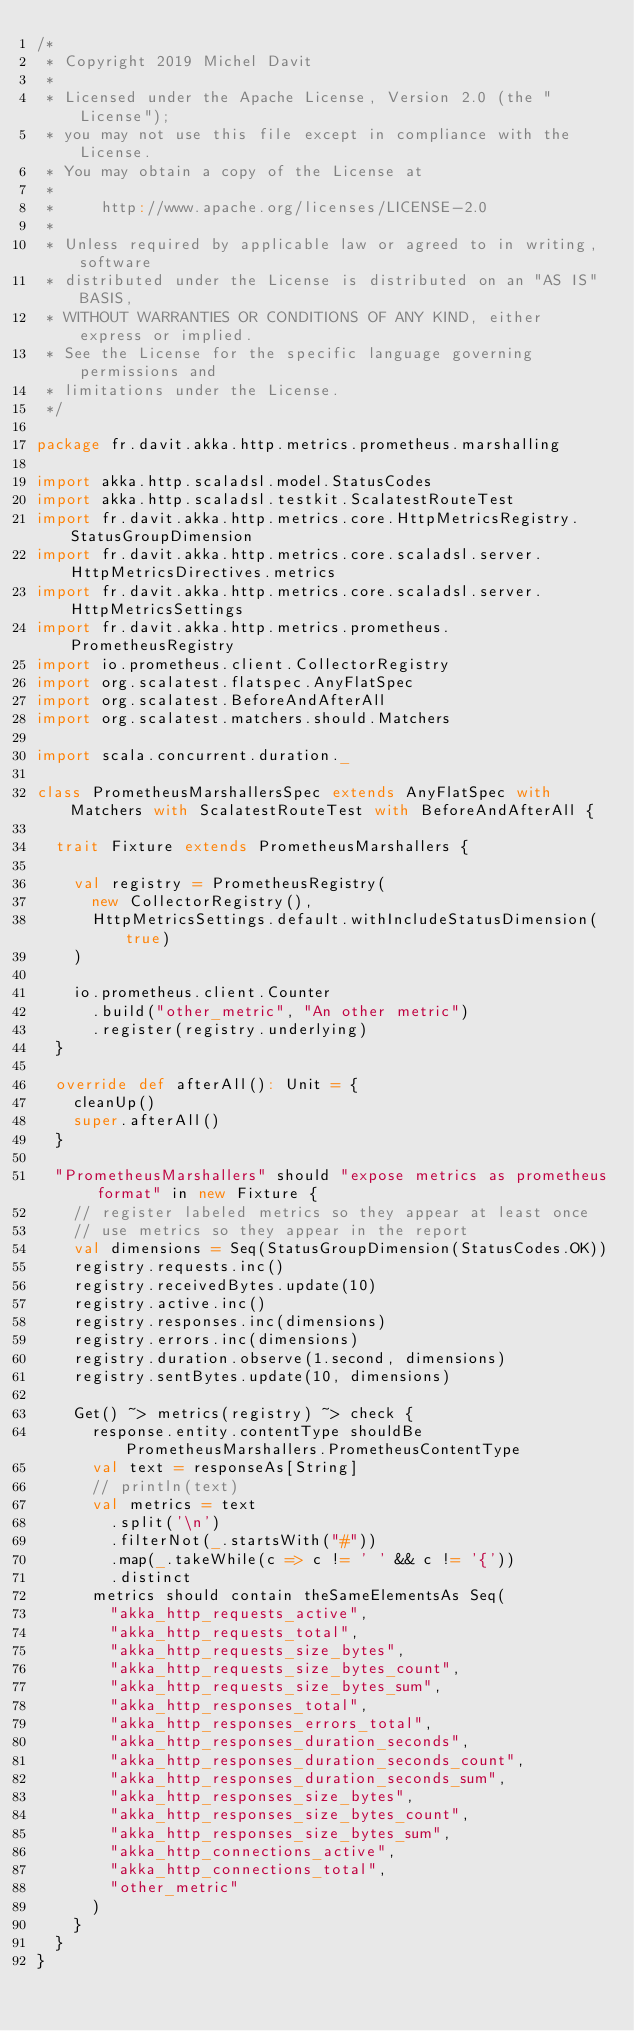Convert code to text. <code><loc_0><loc_0><loc_500><loc_500><_Scala_>/*
 * Copyright 2019 Michel Davit
 *
 * Licensed under the Apache License, Version 2.0 (the "License");
 * you may not use this file except in compliance with the License.
 * You may obtain a copy of the License at
 *
 *     http://www.apache.org/licenses/LICENSE-2.0
 *
 * Unless required by applicable law or agreed to in writing, software
 * distributed under the License is distributed on an "AS IS" BASIS,
 * WITHOUT WARRANTIES OR CONDITIONS OF ANY KIND, either express or implied.
 * See the License for the specific language governing permissions and
 * limitations under the License.
 */

package fr.davit.akka.http.metrics.prometheus.marshalling

import akka.http.scaladsl.model.StatusCodes
import akka.http.scaladsl.testkit.ScalatestRouteTest
import fr.davit.akka.http.metrics.core.HttpMetricsRegistry.StatusGroupDimension
import fr.davit.akka.http.metrics.core.scaladsl.server.HttpMetricsDirectives.metrics
import fr.davit.akka.http.metrics.core.scaladsl.server.HttpMetricsSettings
import fr.davit.akka.http.metrics.prometheus.PrometheusRegistry
import io.prometheus.client.CollectorRegistry
import org.scalatest.flatspec.AnyFlatSpec
import org.scalatest.BeforeAndAfterAll
import org.scalatest.matchers.should.Matchers

import scala.concurrent.duration._

class PrometheusMarshallersSpec extends AnyFlatSpec with Matchers with ScalatestRouteTest with BeforeAndAfterAll {

  trait Fixture extends PrometheusMarshallers {

    val registry = PrometheusRegistry(
      new CollectorRegistry(),
      HttpMetricsSettings.default.withIncludeStatusDimension(true)
    )

    io.prometheus.client.Counter
      .build("other_metric", "An other metric")
      .register(registry.underlying)
  }

  override def afterAll(): Unit = {
    cleanUp()
    super.afterAll()
  }

  "PrometheusMarshallers" should "expose metrics as prometheus format" in new Fixture {
    // register labeled metrics so they appear at least once
    // use metrics so they appear in the report
    val dimensions = Seq(StatusGroupDimension(StatusCodes.OK))
    registry.requests.inc()
    registry.receivedBytes.update(10)
    registry.active.inc()
    registry.responses.inc(dimensions)
    registry.errors.inc(dimensions)
    registry.duration.observe(1.second, dimensions)
    registry.sentBytes.update(10, dimensions)

    Get() ~> metrics(registry) ~> check {
      response.entity.contentType shouldBe PrometheusMarshallers.PrometheusContentType
      val text = responseAs[String]
      // println(text)
      val metrics = text
        .split('\n')
        .filterNot(_.startsWith("#"))
        .map(_.takeWhile(c => c != ' ' && c != '{'))
        .distinct
      metrics should contain theSameElementsAs Seq(
        "akka_http_requests_active",
        "akka_http_requests_total",
        "akka_http_requests_size_bytes",
        "akka_http_requests_size_bytes_count",
        "akka_http_requests_size_bytes_sum",
        "akka_http_responses_total",
        "akka_http_responses_errors_total",
        "akka_http_responses_duration_seconds",
        "akka_http_responses_duration_seconds_count",
        "akka_http_responses_duration_seconds_sum",
        "akka_http_responses_size_bytes",
        "akka_http_responses_size_bytes_count",
        "akka_http_responses_size_bytes_sum",
        "akka_http_connections_active",
        "akka_http_connections_total",
        "other_metric"
      )
    }
  }
}
</code> 